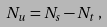Convert formula to latex. <formula><loc_0><loc_0><loc_500><loc_500>N _ { u } = N _ { s } - N _ { t } \, ,</formula> 